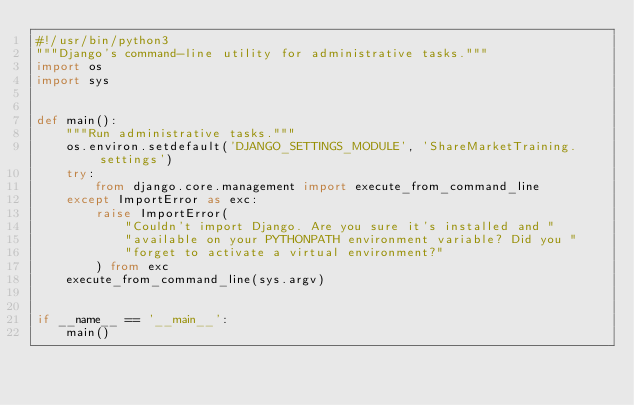<code> <loc_0><loc_0><loc_500><loc_500><_Python_>#!/usr/bin/python3
"""Django's command-line utility for administrative tasks."""
import os
import sys


def main():
    """Run administrative tasks."""
    os.environ.setdefault('DJANGO_SETTINGS_MODULE', 'ShareMarketTraining.settings')
    try:
        from django.core.management import execute_from_command_line
    except ImportError as exc:
        raise ImportError(
            "Couldn't import Django. Are you sure it's installed and "
            "available on your PYTHONPATH environment variable? Did you "
            "forget to activate a virtual environment?"
        ) from exc
    execute_from_command_line(sys.argv)


if __name__ == '__main__':
    main()
</code> 